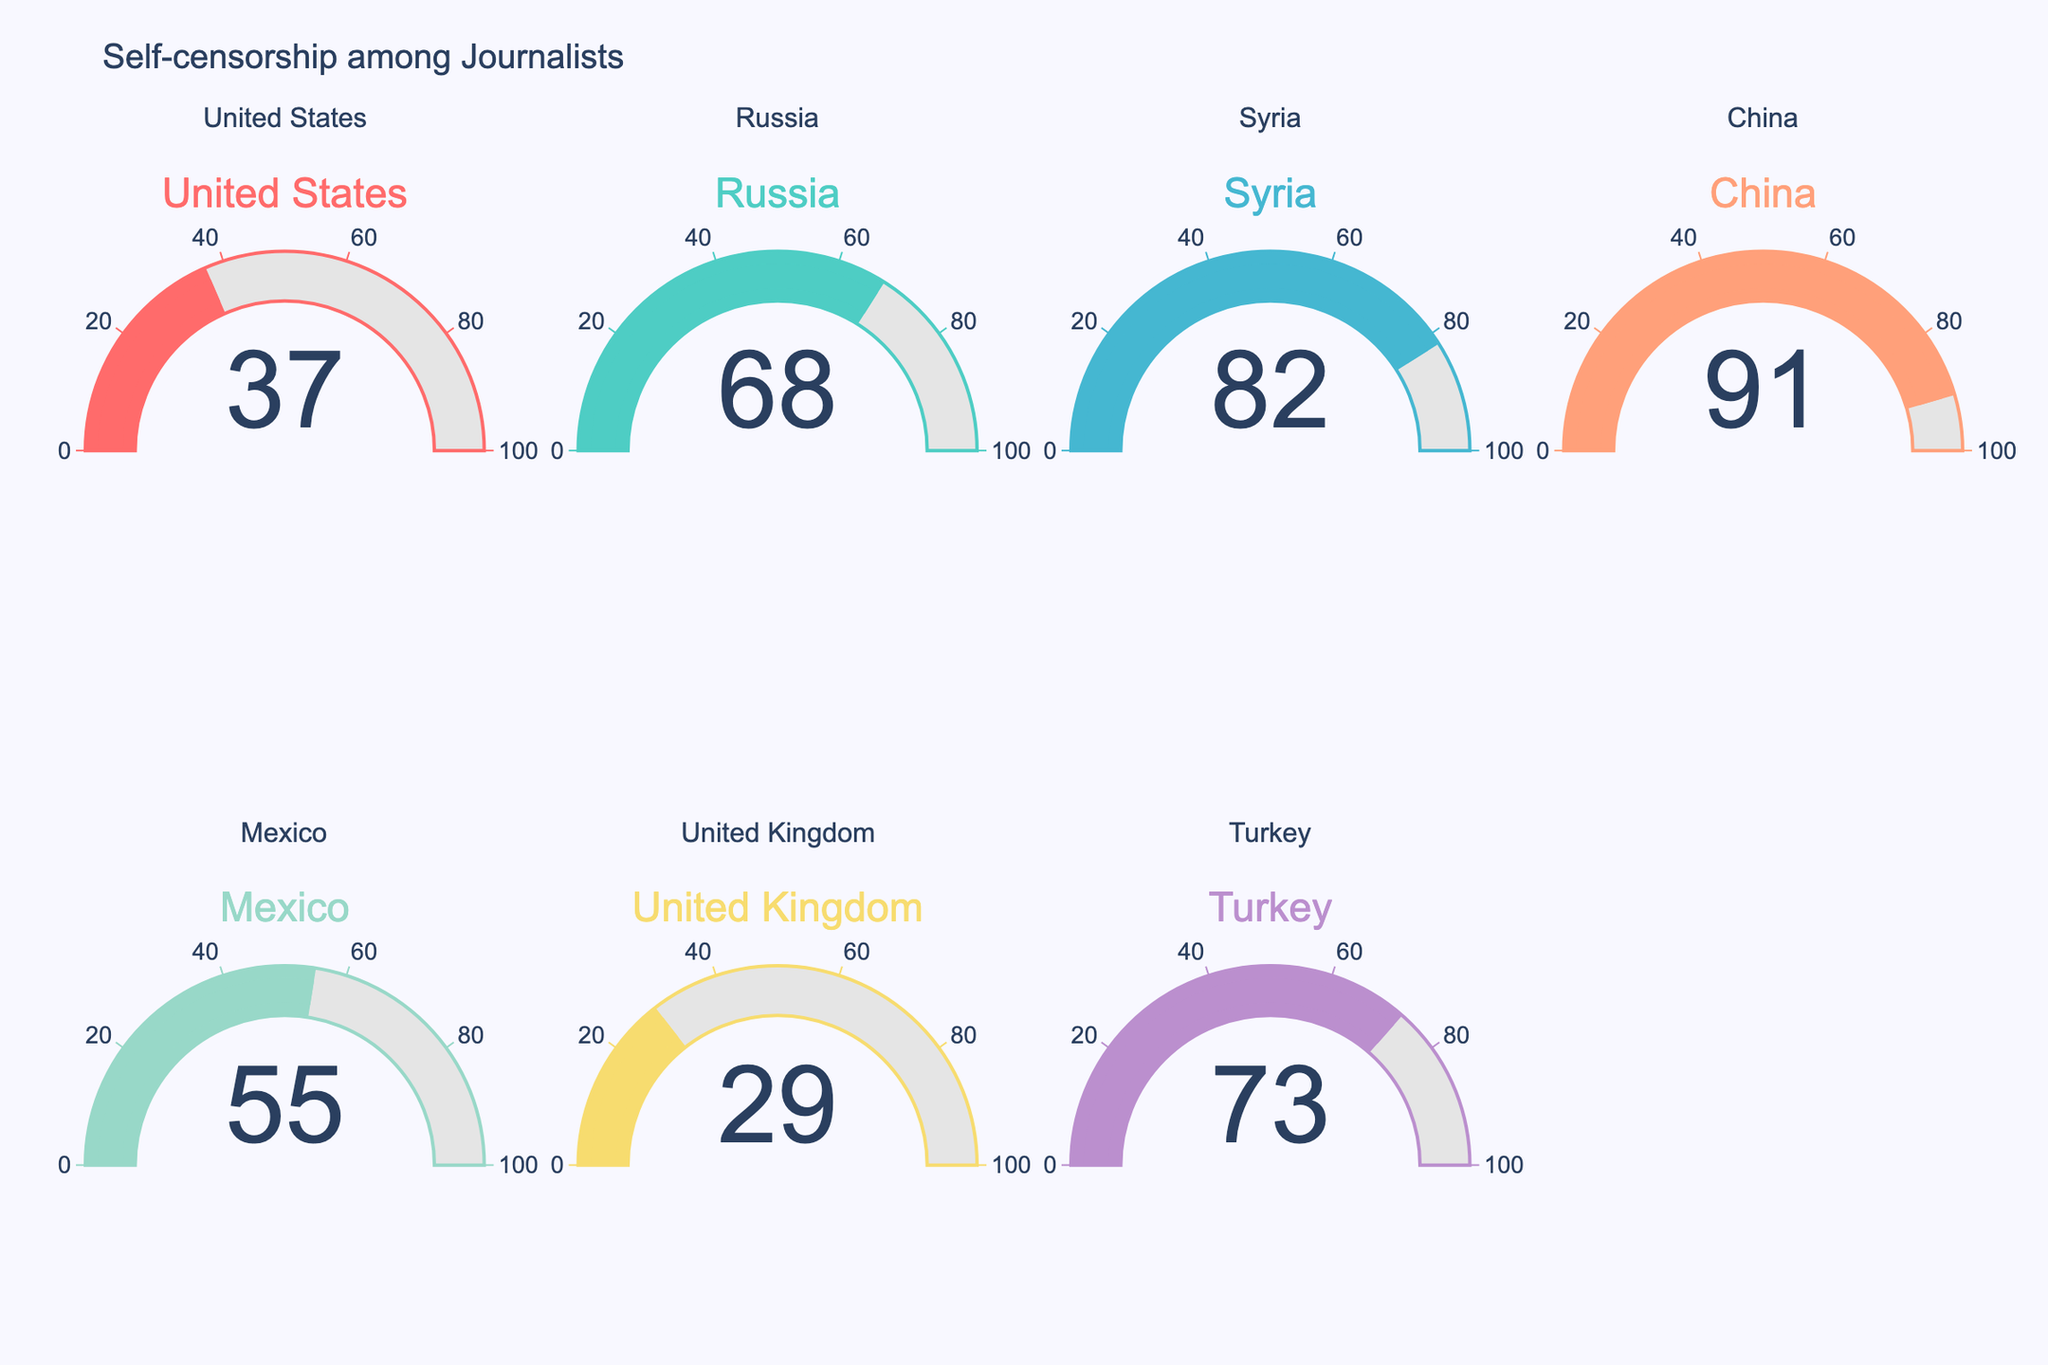How many countries are included in the figure? Count the number of distinct gauges displayed in the figure, which represents different countries.
Answer: 7 Which country has the highest percentage of journalists reporting self-censorship? Look at the gauge with the maximum value. The highest percentage is in the gauge labeled "China".
Answer: China What is the self-censorship percentage in Mexico? Find the gauge labeled "Mexico" and note the number displayed.
Answer: 55 Compare the self-censorship percentage between the United States and Russia. Which is higher? Identify the gauges labeled "United States" and "Russia". The number for Russia (68) is higher than the United States (37).
Answer: Russia What's the average self-censorship percentage across all countries? Sum the self-censorship percentages of all countries (37 + 68 + 82 + 91 + 55 + 29 + 73) and divide by the number of countries (7). Calculation: (37 + 68 + 82 + 91 + 55 + 29 + 73) / 7 = 435 / 7 = 62.14.
Answer: 62.14 Which country has the lowest percentage of journalists reporting self-censorship? Look at the gauge with the minimum value. The lowest percentage is in the gauge labeled "United Kingdom".
Answer: United Kingdom What is the total self-censorship percentage of all countries combined? Add up the percentages from all gauges. Calculation: 37 + 68 + 82 + 91 + 55 + 29 + 73 = 435.
Answer: 435 What is the median self-censorship percentage among these countries? Arrange the percentages in ascending order: 29, 37, 55, 68, 73, 82, 91. The median is the middle value, which is 68.
Answer: 68 Between Turkey and Syria, which country has a higher self-censorship percentage? Identify the gauges labeled "Turkey" and "Syria". The number for Syria (82) is higher than Turkey (73).
Answer: Syria 